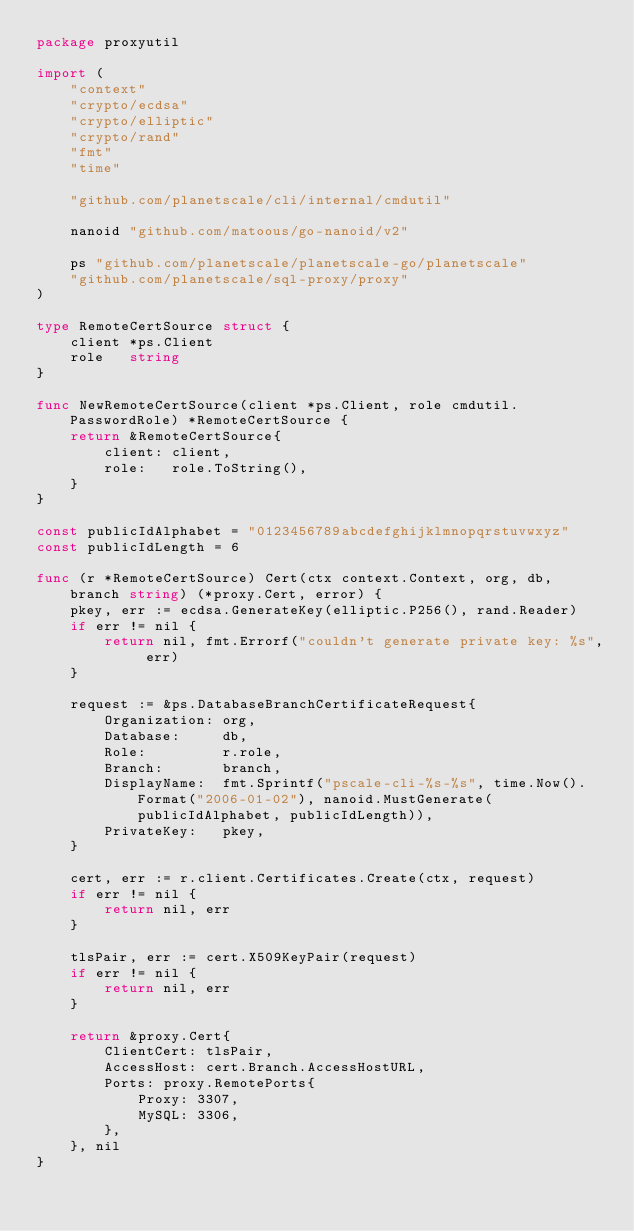Convert code to text. <code><loc_0><loc_0><loc_500><loc_500><_Go_>package proxyutil

import (
	"context"
	"crypto/ecdsa"
	"crypto/elliptic"
	"crypto/rand"
	"fmt"
	"time"

	"github.com/planetscale/cli/internal/cmdutil"

	nanoid "github.com/matoous/go-nanoid/v2"

	ps "github.com/planetscale/planetscale-go/planetscale"
	"github.com/planetscale/sql-proxy/proxy"
)

type RemoteCertSource struct {
	client *ps.Client
	role   string
}

func NewRemoteCertSource(client *ps.Client, role cmdutil.PasswordRole) *RemoteCertSource {
	return &RemoteCertSource{
		client: client,
		role:   role.ToString(),
	}
}

const publicIdAlphabet = "0123456789abcdefghijklmnopqrstuvwxyz"
const publicIdLength = 6

func (r *RemoteCertSource) Cert(ctx context.Context, org, db, branch string) (*proxy.Cert, error) {
	pkey, err := ecdsa.GenerateKey(elliptic.P256(), rand.Reader)
	if err != nil {
		return nil, fmt.Errorf("couldn't generate private key: %s", err)
	}

	request := &ps.DatabaseBranchCertificateRequest{
		Organization: org,
		Database:     db,
		Role:         r.role,
		Branch:       branch,
		DisplayName:  fmt.Sprintf("pscale-cli-%s-%s", time.Now().Format("2006-01-02"), nanoid.MustGenerate(publicIdAlphabet, publicIdLength)),
		PrivateKey:   pkey,
	}

	cert, err := r.client.Certificates.Create(ctx, request)
	if err != nil {
		return nil, err
	}

	tlsPair, err := cert.X509KeyPair(request)
	if err != nil {
		return nil, err
	}

	return &proxy.Cert{
		ClientCert: tlsPair,
		AccessHost: cert.Branch.AccessHostURL,
		Ports: proxy.RemotePorts{
			Proxy: 3307,
			MySQL: 3306,
		},
	}, nil
}
</code> 